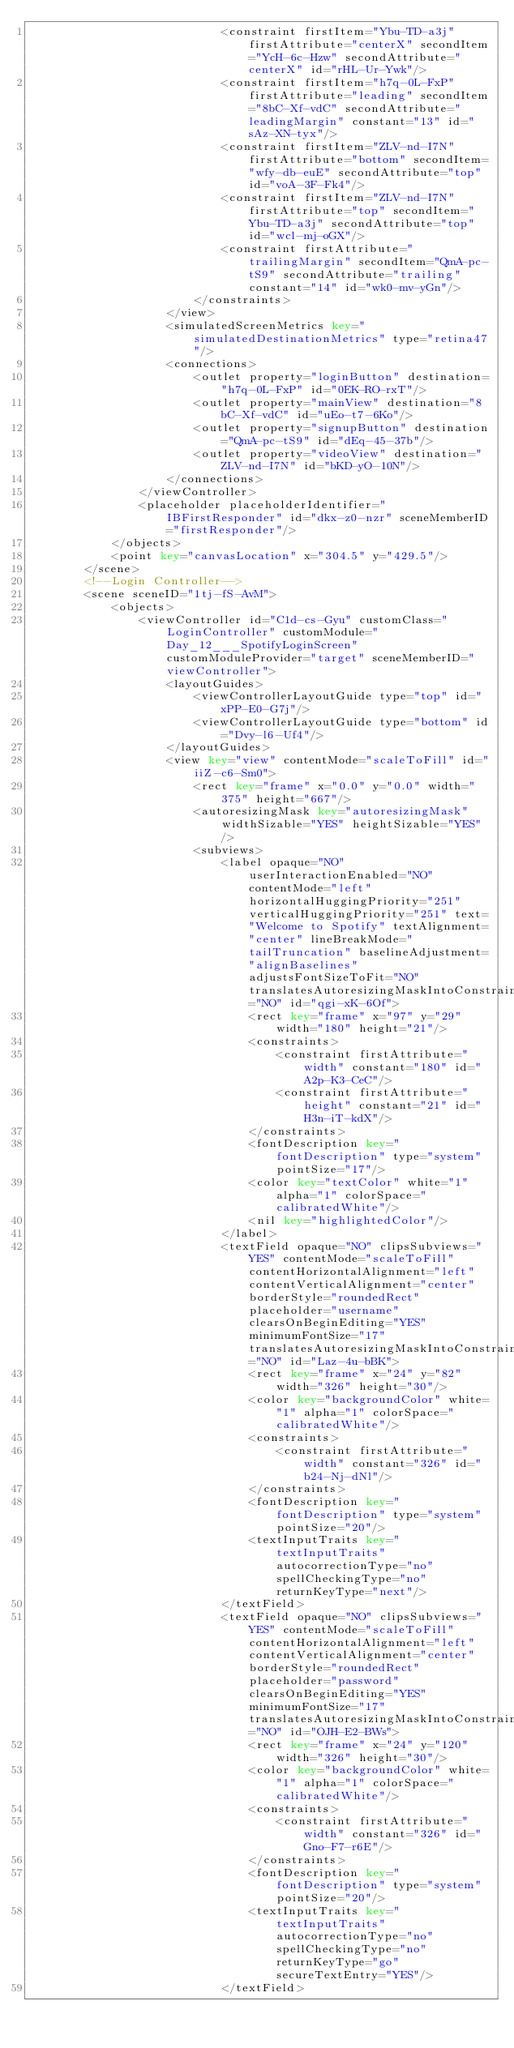<code> <loc_0><loc_0><loc_500><loc_500><_XML_>                            <constraint firstItem="Ybu-TD-a3j" firstAttribute="centerX" secondItem="YcH-6c-Hzw" secondAttribute="centerX" id="rHL-Ur-Ywk"/>
                            <constraint firstItem="h7q-0L-FxP" firstAttribute="leading" secondItem="8bC-Xf-vdC" secondAttribute="leadingMargin" constant="13" id="sAz-XN-tyx"/>
                            <constraint firstItem="ZLV-nd-I7N" firstAttribute="bottom" secondItem="wfy-db-euE" secondAttribute="top" id="voA-3F-Fk4"/>
                            <constraint firstItem="ZLV-nd-I7N" firstAttribute="top" secondItem="Ybu-TD-a3j" secondAttribute="top" id="wcl-mj-oGX"/>
                            <constraint firstAttribute="trailingMargin" secondItem="QmA-pc-tS9" secondAttribute="trailing" constant="14" id="wk0-mv-yGn"/>
                        </constraints>
                    </view>
                    <simulatedScreenMetrics key="simulatedDestinationMetrics" type="retina47"/>
                    <connections>
                        <outlet property="loginButton" destination="h7q-0L-FxP" id="0EK-RO-rxT"/>
                        <outlet property="mainView" destination="8bC-Xf-vdC" id="uEo-t7-6Ko"/>
                        <outlet property="signupButton" destination="QmA-pc-tS9" id="dEq-45-37b"/>
                        <outlet property="videoView" destination="ZLV-nd-I7N" id="bKD-yO-10N"/>
                    </connections>
                </viewController>
                <placeholder placeholderIdentifier="IBFirstResponder" id="dkx-z0-nzr" sceneMemberID="firstResponder"/>
            </objects>
            <point key="canvasLocation" x="304.5" y="429.5"/>
        </scene>
        <!--Login Controller-->
        <scene sceneID="1tj-fS-AvM">
            <objects>
                <viewController id="C1d-cs-Gyu" customClass="LoginController" customModule="Day_12___SpotifyLoginScreen" customModuleProvider="target" sceneMemberID="viewController">
                    <layoutGuides>
                        <viewControllerLayoutGuide type="top" id="xPP-E0-G7j"/>
                        <viewControllerLayoutGuide type="bottom" id="Dvy-l6-Uf4"/>
                    </layoutGuides>
                    <view key="view" contentMode="scaleToFill" id="iiZ-c6-Sm0">
                        <rect key="frame" x="0.0" y="0.0" width="375" height="667"/>
                        <autoresizingMask key="autoresizingMask" widthSizable="YES" heightSizable="YES"/>
                        <subviews>
                            <label opaque="NO" userInteractionEnabled="NO" contentMode="left" horizontalHuggingPriority="251" verticalHuggingPriority="251" text="Welcome to Spotify" textAlignment="center" lineBreakMode="tailTruncation" baselineAdjustment="alignBaselines" adjustsFontSizeToFit="NO" translatesAutoresizingMaskIntoConstraints="NO" id="qgi-xK-6Of">
                                <rect key="frame" x="97" y="29" width="180" height="21"/>
                                <constraints>
                                    <constraint firstAttribute="width" constant="180" id="A2p-K3-CeC"/>
                                    <constraint firstAttribute="height" constant="21" id="H3n-iT-kdX"/>
                                </constraints>
                                <fontDescription key="fontDescription" type="system" pointSize="17"/>
                                <color key="textColor" white="1" alpha="1" colorSpace="calibratedWhite"/>
                                <nil key="highlightedColor"/>
                            </label>
                            <textField opaque="NO" clipsSubviews="YES" contentMode="scaleToFill" contentHorizontalAlignment="left" contentVerticalAlignment="center" borderStyle="roundedRect" placeholder="username" clearsOnBeginEditing="YES" minimumFontSize="17" translatesAutoresizingMaskIntoConstraints="NO" id="Laz-4u-bBK">
                                <rect key="frame" x="24" y="82" width="326" height="30"/>
                                <color key="backgroundColor" white="1" alpha="1" colorSpace="calibratedWhite"/>
                                <constraints>
                                    <constraint firstAttribute="width" constant="326" id="b24-Nj-dNl"/>
                                </constraints>
                                <fontDescription key="fontDescription" type="system" pointSize="20"/>
                                <textInputTraits key="textInputTraits" autocorrectionType="no" spellCheckingType="no" returnKeyType="next"/>
                            </textField>
                            <textField opaque="NO" clipsSubviews="YES" contentMode="scaleToFill" contentHorizontalAlignment="left" contentVerticalAlignment="center" borderStyle="roundedRect" placeholder="password" clearsOnBeginEditing="YES" minimumFontSize="17" translatesAutoresizingMaskIntoConstraints="NO" id="OJH-E2-BWs">
                                <rect key="frame" x="24" y="120" width="326" height="30"/>
                                <color key="backgroundColor" white="1" alpha="1" colorSpace="calibratedWhite"/>
                                <constraints>
                                    <constraint firstAttribute="width" constant="326" id="Gno-F7-r6E"/>
                                </constraints>
                                <fontDescription key="fontDescription" type="system" pointSize="20"/>
                                <textInputTraits key="textInputTraits" autocorrectionType="no" spellCheckingType="no" returnKeyType="go" secureTextEntry="YES"/>
                            </textField></code> 